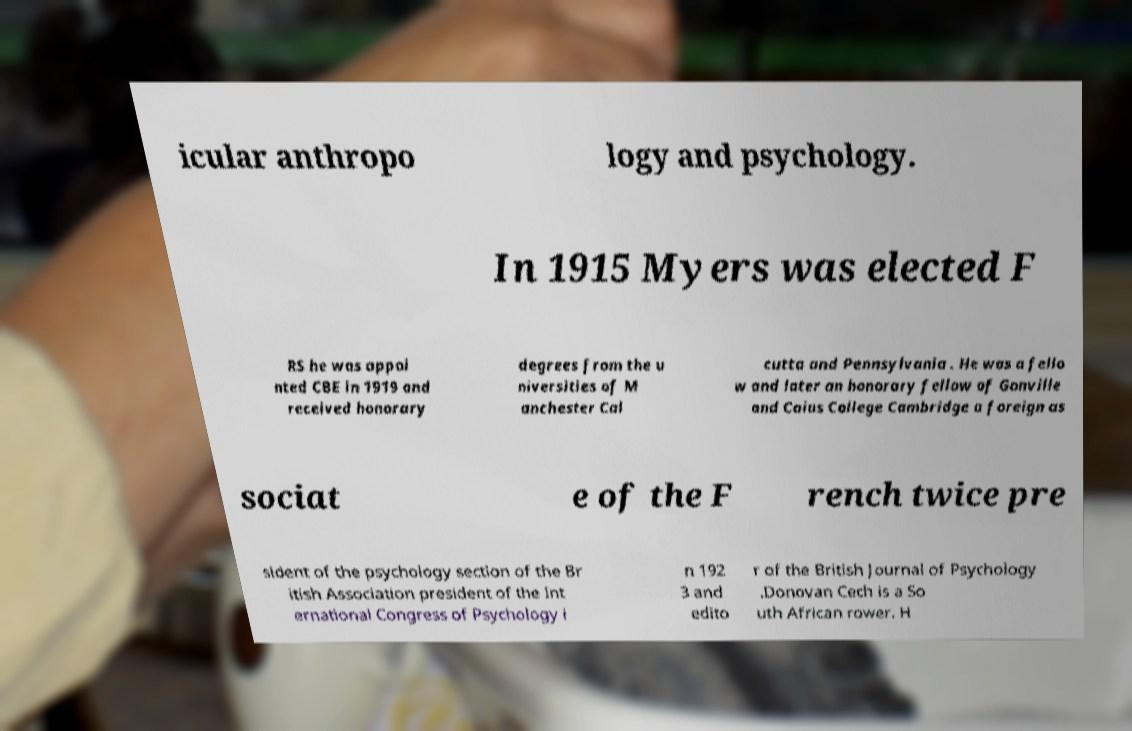What messages or text are displayed in this image? I need them in a readable, typed format. icular anthropo logy and psychology. In 1915 Myers was elected F RS he was appoi nted CBE in 1919 and received honorary degrees from the u niversities of M anchester Cal cutta and Pennsylvania . He was a fello w and later an honorary fellow of Gonville and Caius College Cambridge a foreign as sociat e of the F rench twice pre sident of the psychology section of the Br itish Association president of the Int ernational Congress of Psychology i n 192 3 and edito r of the British Journal of Psychology .Donovan Cech is a So uth African rower. H 